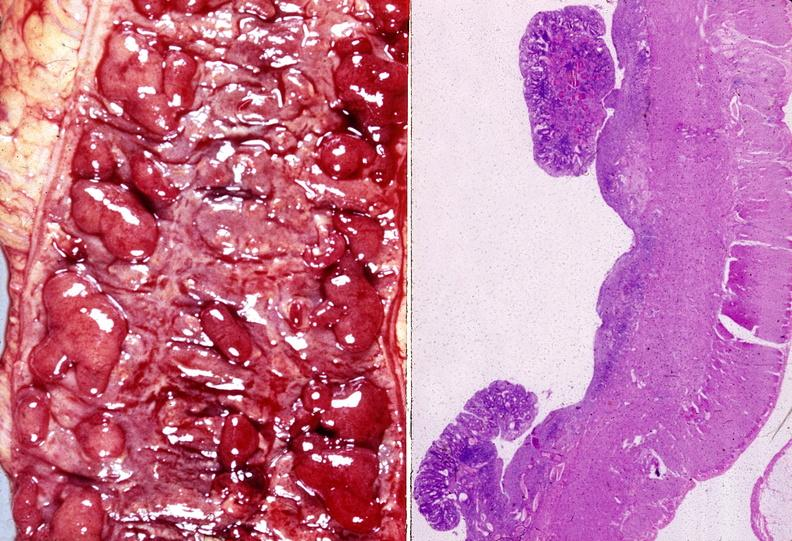where does this belong to?
Answer the question using a single word or phrase. Gastrointestinal system 